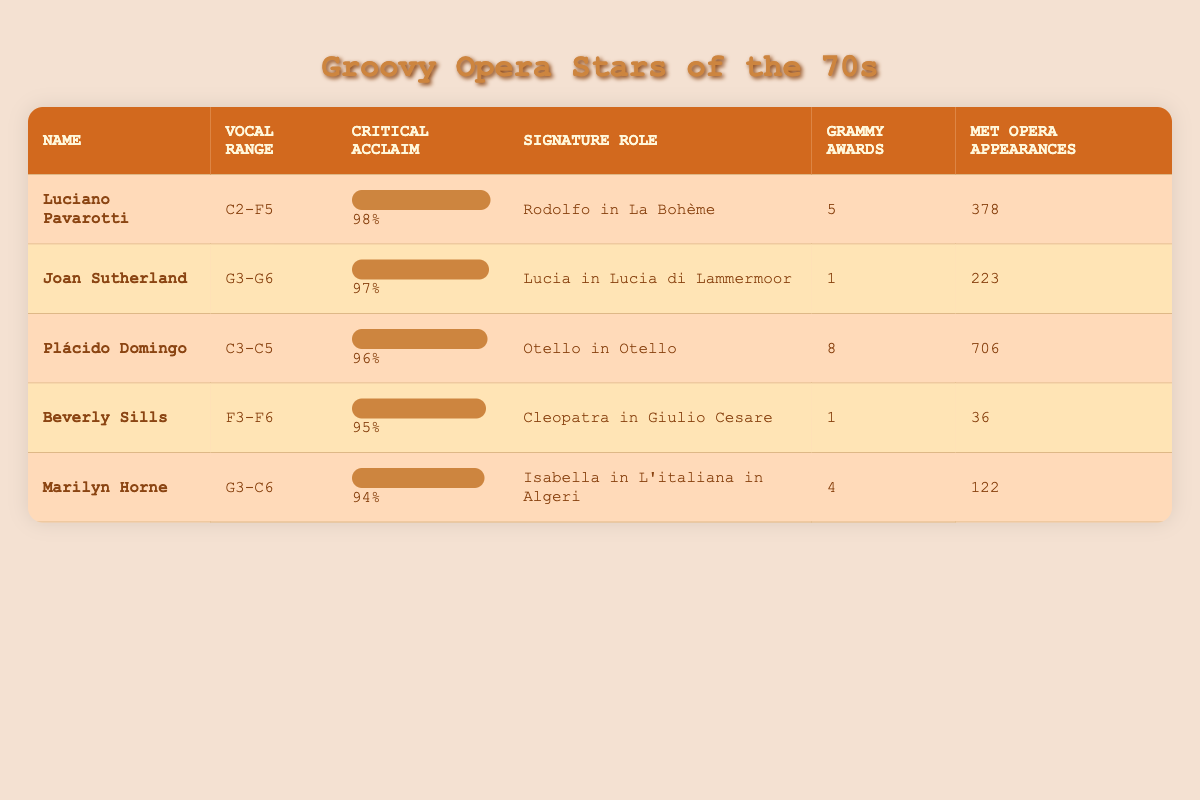What is the vocal range of Plácido Domingo? Plácido Domingo's vocal range is listed in the table as C3-C5.
Answer: C3-C5 Who has the highest critical acclaim score? Luciano Pavarotti has the highest critical acclaim score of 98%.
Answer: 98% How many Grammy Awards did Joan Sutherland win? The table shows that Joan Sutherland won 1 Grammy Award.
Answer: 1 Which singer has the most Met Opera appearances, and how many? Plácido Domingo has the most Met Opera appearances listed at 706.
Answer: Plácido Domingo, 706 What is the difference in critical acclaim between Luciano Pavarotti and Marilyn Horne? Luciano Pavarotti has a critical acclaim of 98%, while Marilyn Horne has 94%. The difference is 98% - 94% = 4%.
Answer: 4% Is Beverly Sills's signature role Rodolfo in La Bohème? No, Beverly Sills's signature role is Cleopatra in Giulio Cesare, not Rodolfo in La Bohème.
Answer: No Which opera singer has the largest vocal range? Joan Sutherland has the largest vocal range of G3-G6, which spans three octaves from G3 to G6.
Answer: G3-G6 If you combine the Grammy Awards of Luciano Pavarotti and Marilyn Horne, what is the total? Luciano Pavarotti has 5 Grammy Awards, and Marilyn Horne has 4. The total is 5 + 4 = 9.
Answer: 9 Do more than half of the singers listed have 5 or more Grammy Awards? Yes, three singers (Luciano Pavarotti, Plácido Domingo, and Marilyn Horne) have 5 or more Grammy Awards, out of five total singers.
Answer: Yes 